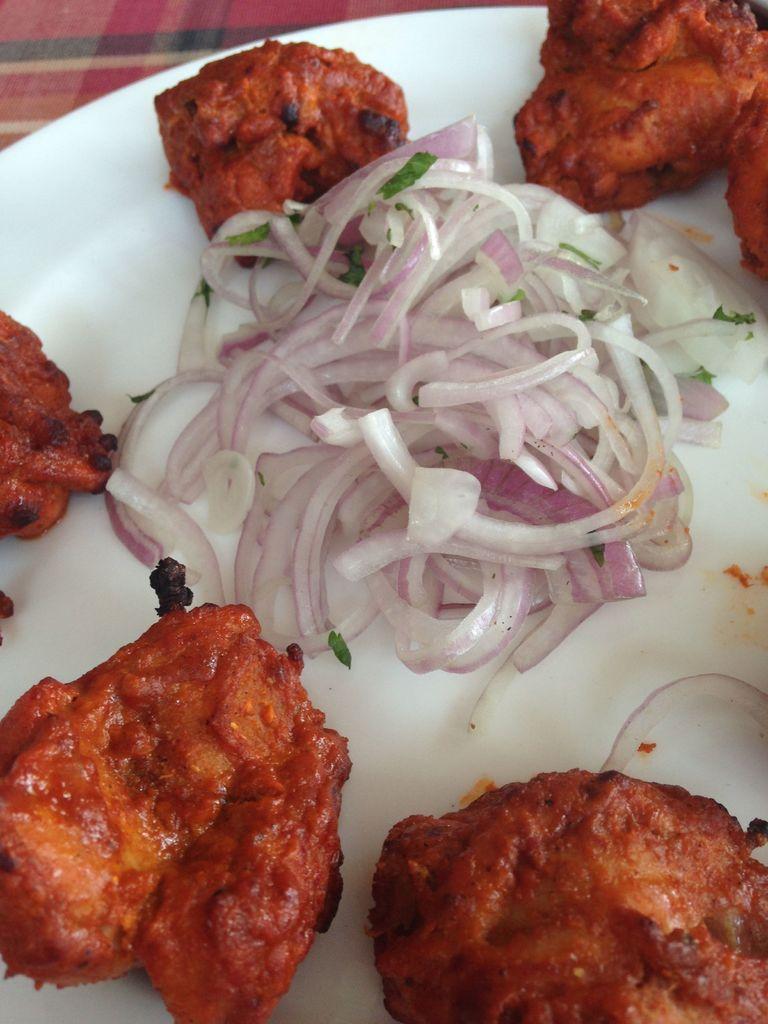Can you describe this image briefly? In this image there is a plate, in that place there is food item. 